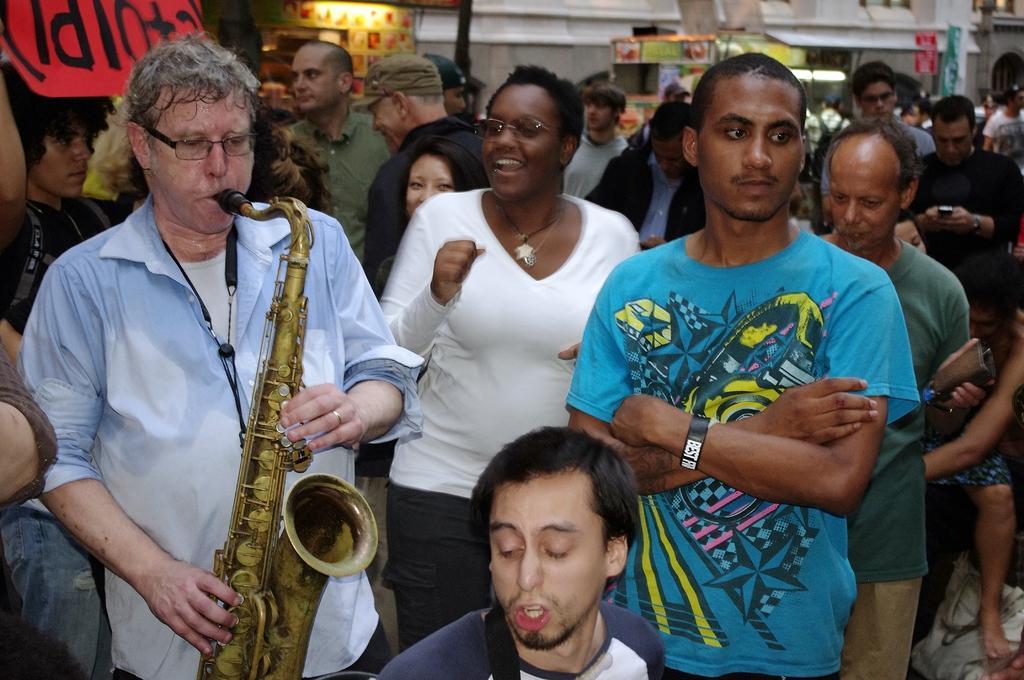Please provide a concise description of this image. This image is taken outdoors. In the middle of the image many people are standing on the floor. On the left side of the image a man is standing and playing music with a trampoline. In the background there is a wall and there are a few stalls and there is a board with a text on it. 